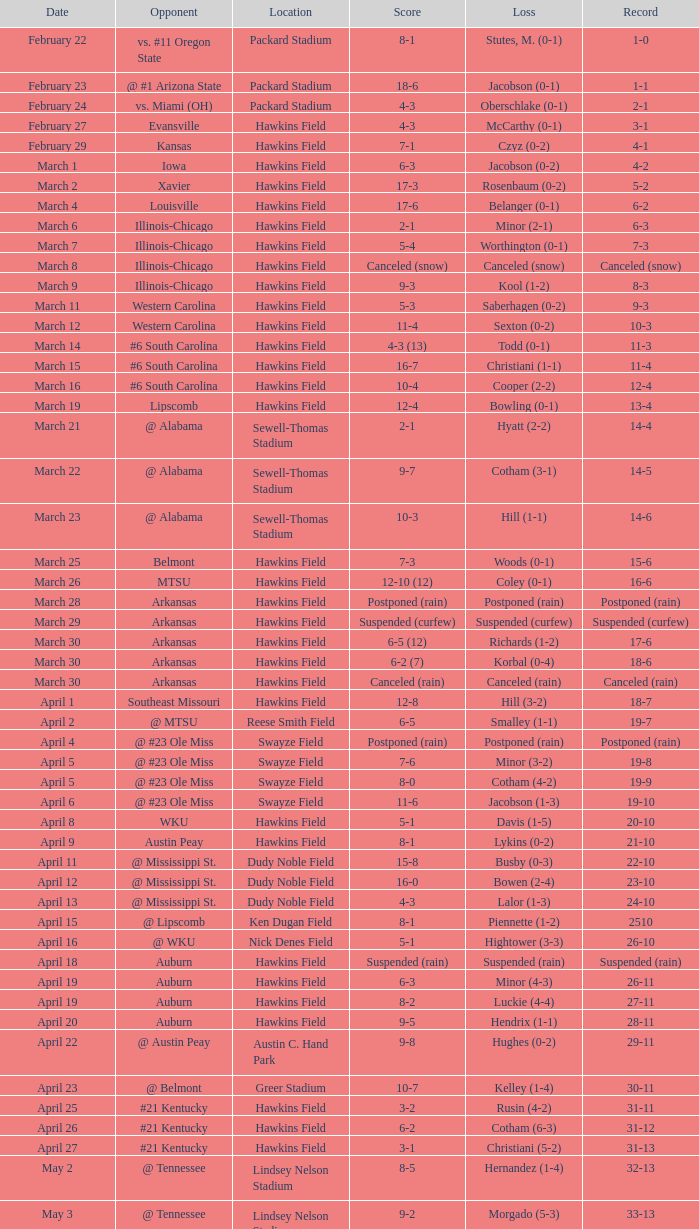What was the venue of the match when the tally was 2-1? Packard Stadium. 